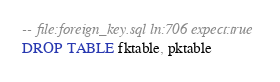Convert code to text. <code><loc_0><loc_0><loc_500><loc_500><_SQL_>-- file:foreign_key.sql ln:706 expect:true
DROP TABLE fktable, pktable
</code> 